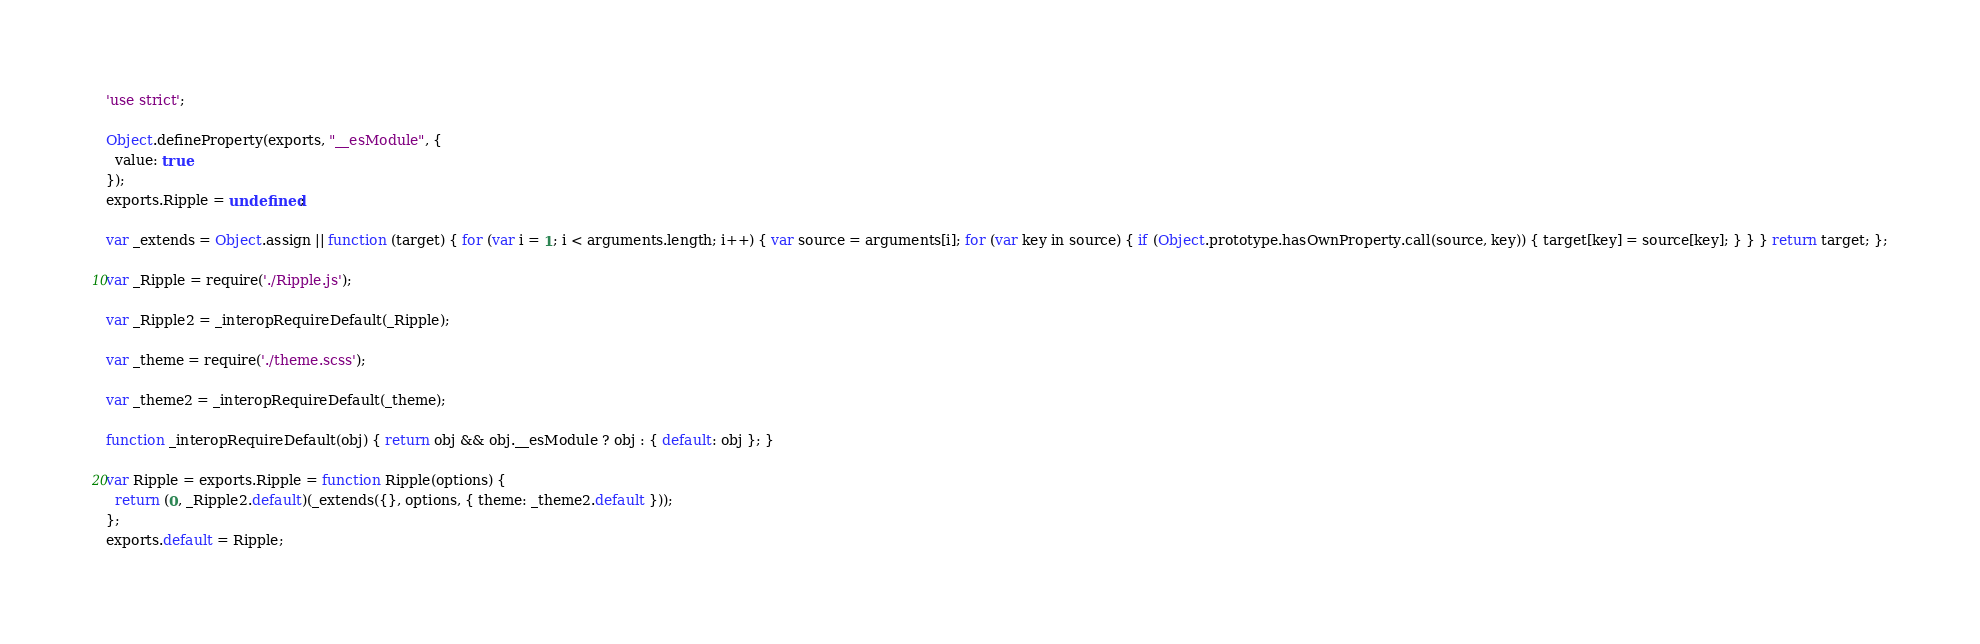Convert code to text. <code><loc_0><loc_0><loc_500><loc_500><_JavaScript_>'use strict';

Object.defineProperty(exports, "__esModule", {
  value: true
});
exports.Ripple = undefined;

var _extends = Object.assign || function (target) { for (var i = 1; i < arguments.length; i++) { var source = arguments[i]; for (var key in source) { if (Object.prototype.hasOwnProperty.call(source, key)) { target[key] = source[key]; } } } return target; };

var _Ripple = require('./Ripple.js');

var _Ripple2 = _interopRequireDefault(_Ripple);

var _theme = require('./theme.scss');

var _theme2 = _interopRequireDefault(_theme);

function _interopRequireDefault(obj) { return obj && obj.__esModule ? obj : { default: obj }; }

var Ripple = exports.Ripple = function Ripple(options) {
  return (0, _Ripple2.default)(_extends({}, options, { theme: _theme2.default }));
};
exports.default = Ripple;</code> 